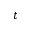Convert formula to latex. <formula><loc_0><loc_0><loc_500><loc_500>t</formula> 